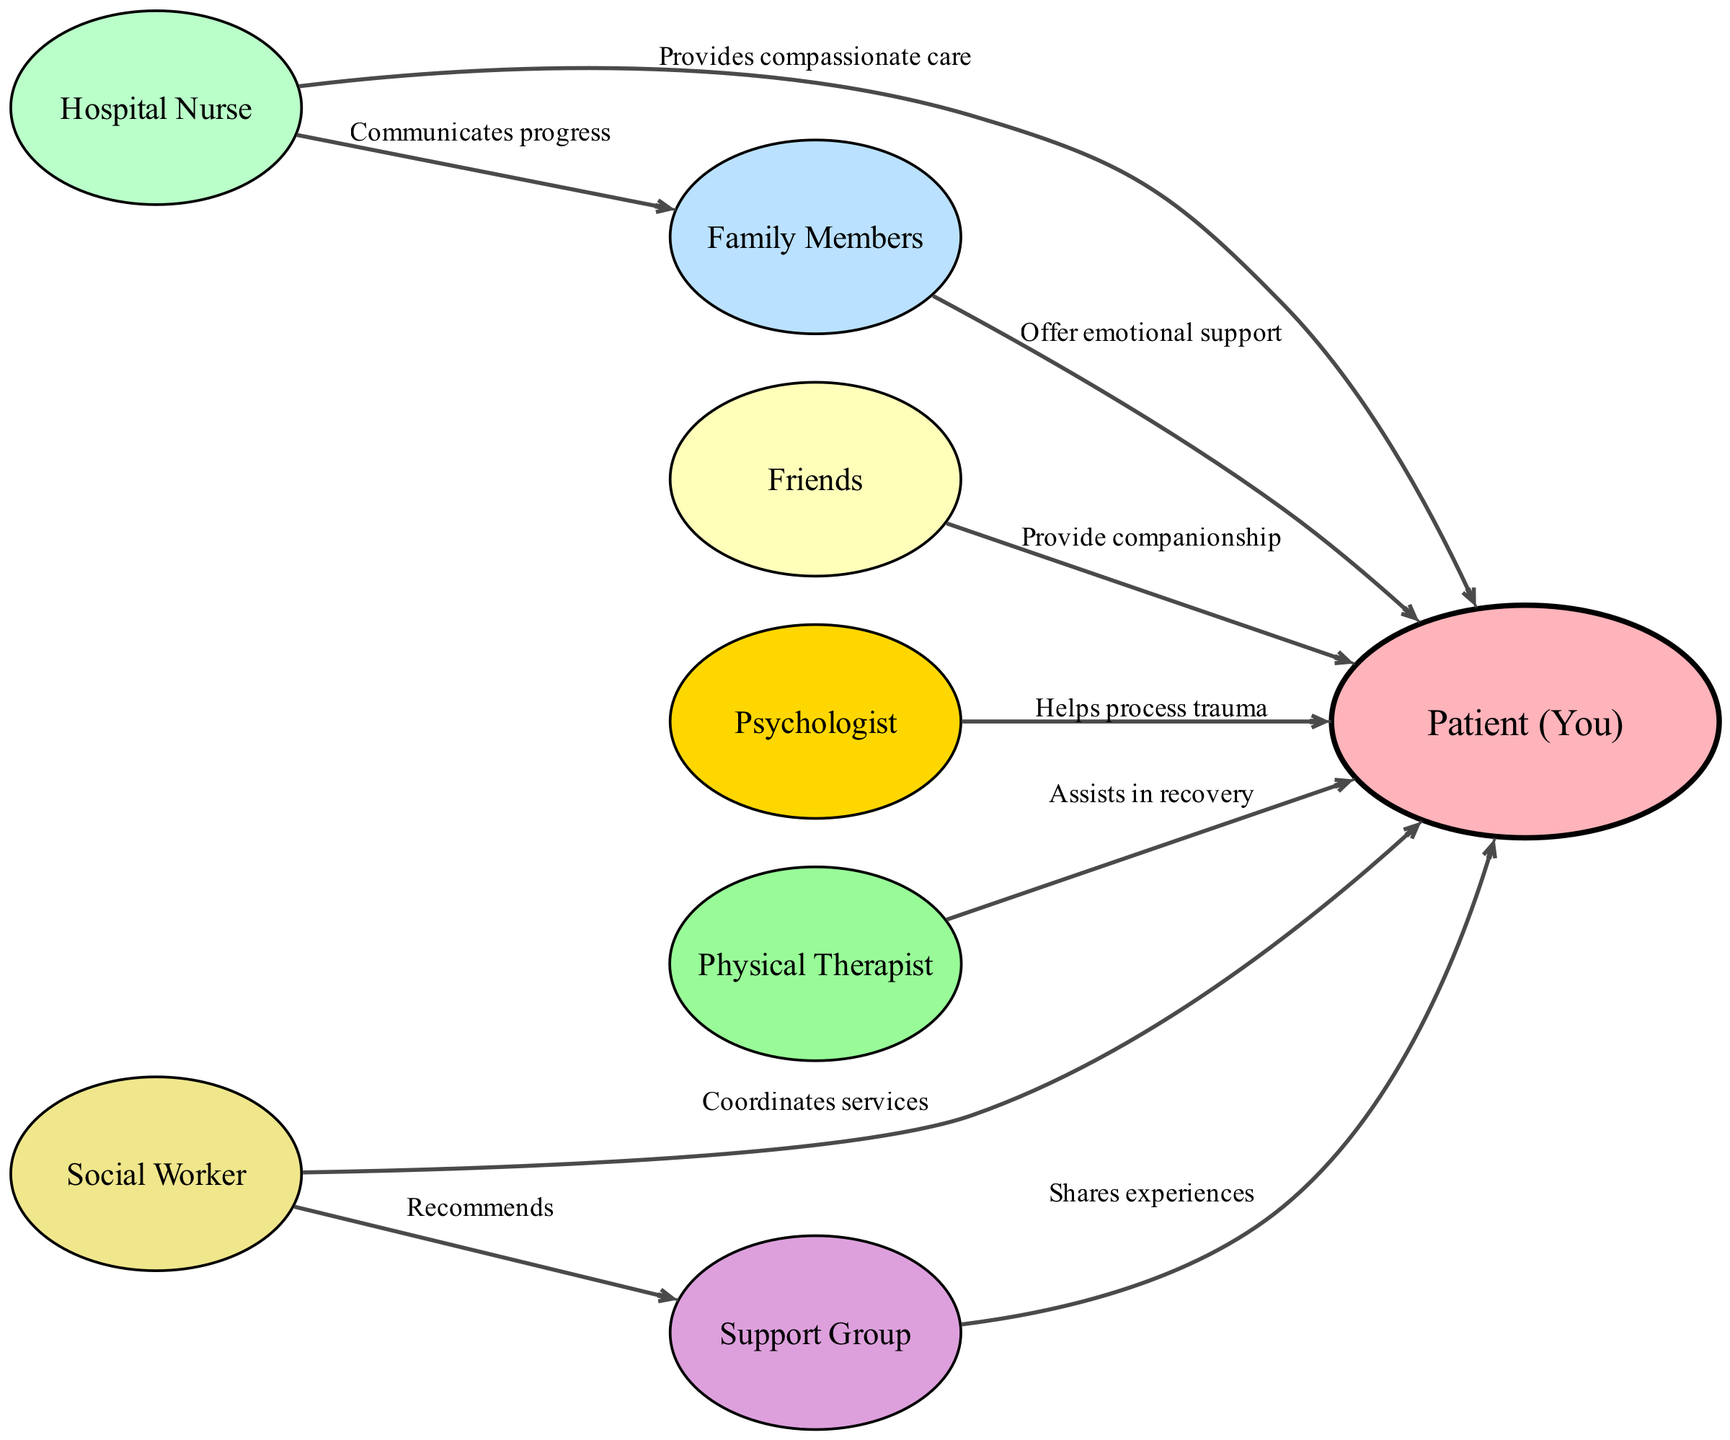What is the total number of nodes in the diagram? The diagram includes eight distinct entities that represent the support network, which are Patient (You), Hospital Nurse, Family Members, Friends, Psychologist, Physical Therapist, Support Group, and Social Worker. Thus, counting these nodes gives a total of eight.
Answer: 8 Who provides compassionate care to the patient? The Hospital Nurse is specifically labeled as providing compassionate care to the Patient (You) within the diagram.
Answer: Hospital Nurse How many edges originate from the Hospital Nurse? The Hospital Nurse has two outgoing connections in the diagram: one to the Patient (You) and another to Family Members. This indicates that there are two edges originating from the Hospital Nurse.
Answer: 2 What type of support do Friends provide to the patient? Friends are depicted in the diagram as providing companionship to the Patient (You), highlighting their role as a source of social support.
Answer: Provide companionship Which professional helps the patient process trauma? The Psychologist is identified in the diagram as assisting the Patient (You) in processing trauma, making this role essential in the healing process.
Answer: Psychologist Which two nodes are directly connected to the Support Group? In the diagram, the Support Group is connected from the Social Worker, who recommends it to the Patient (You), illustrating a direct relationship. Therefore, the two nodes directly associated with the Support Group are the Patient (You) and Social Worker.
Answer: Patient (You), Social Worker How does the Social Worker interact with the Support Group? The Social Worker is depicted in the diagram as recommending the Support Group. This relationship indicates a guiding role of the Social Worker towards accessing the support group services for the Patient (You).
Answer: Recommends What type of assistance does the Physical Therapist provide? The Physical Therapist is labeled in the diagram as assisting in the recovery of the Patient (You), showcasing their role in the patient's physical rehabilitation process post-accident.
Answer: Assists in recovery How does the Hospital Nurse support Family Members? The Hospital Nurse communicates progress to Family Members in the diagram, indicating they play a role in keeping family informed about the Patient's condition.
Answer: Communicates progress 